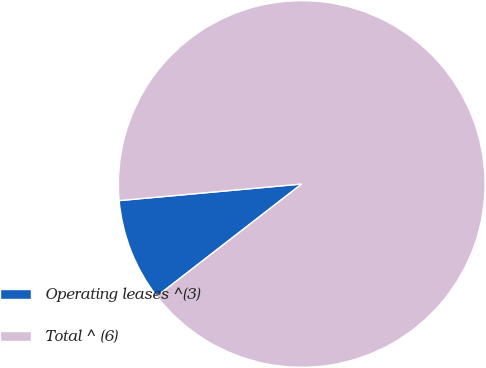<chart> <loc_0><loc_0><loc_500><loc_500><pie_chart><fcel>Operating leases ^(3)<fcel>Total ^ (6)<nl><fcel>9.05%<fcel>90.95%<nl></chart> 